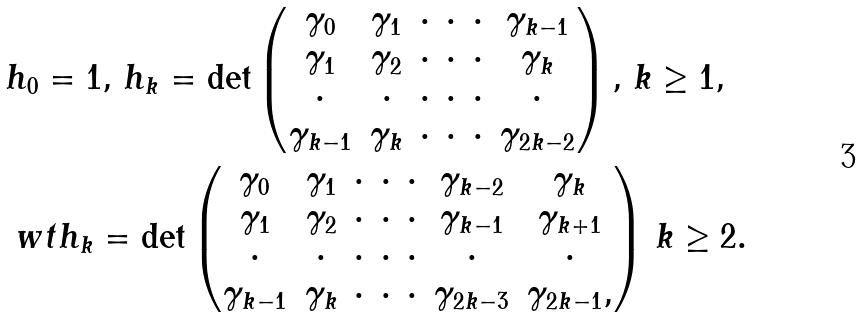<formula> <loc_0><loc_0><loc_500><loc_500>& h _ { 0 } = 1 , \, h _ { k } = \det \begin{pmatrix} \gamma _ { 0 } & \gamma _ { 1 } & \cdot & \cdot & \cdot & \gamma _ { k - 1 } \\ \gamma _ { 1 } & \gamma _ { 2 } & \cdot & \cdot & \cdot & \gamma _ { k } \\ \cdot & \cdot & \cdot & \cdot & \cdot & \cdot \\ \gamma _ { k - 1 } & \gamma _ { k } & \cdot & \cdot & \cdot & \gamma _ { 2 k - 2 } \end{pmatrix} , \, k \geq 1 , \\ & \ w t h _ { k } = \det \begin{pmatrix} \gamma _ { 0 } & \gamma _ { 1 } & \cdot & \cdot & \cdot & \gamma _ { k - 2 } & \gamma _ { k } \\ \gamma _ { 1 } & \gamma _ { 2 } & \cdot & \cdot & \cdot & \gamma _ { k - 1 } & \gamma _ { k + 1 } \\ \cdot & \cdot & \cdot & \cdot & \cdot & \cdot & \cdot \\ \gamma _ { k - 1 } & \gamma _ { k } & \cdot & \cdot & \cdot & \gamma _ { 2 k - 3 } & \gamma _ { 2 k - 1 } , \end{pmatrix} \, k \geq 2 .</formula> 